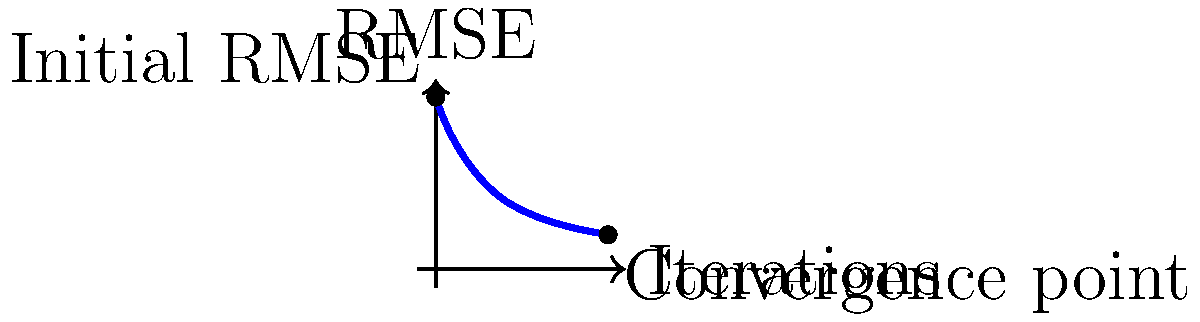Consider a collaborative filtering algorithm for matrix completion, where the convergence is measured by the Root Mean Square Error (RMSE). The graph shows the convergence behavior of the algorithm over iterations. If the algorithm is considered to have converged when the change in RMSE between consecutive iterations is less than ε, and the RMSE function is given by $f(x) = 4e^{-0.4x} + 1$, where x is the number of iterations, at what iteration does the algorithm converge for ε = 0.01? To solve this problem, we need to follow these steps:

1) The convergence criterion is met when the change in RMSE between consecutive iterations is less than ε = 0.01.

2) We can express this mathematically as:
   $|f(x+1) - f(x)| < 0.01$

3) Substituting the given function:
   $|(4e^{-0.4(x+1)} + 1) - (4e^{-0.4x} + 1)| < 0.01$

4) Simplifying:
   $|4e^{-0.4(x+1)} - 4e^{-0.4x}| < 0.01$

5) Factor out $4e^{-0.4x}$:
   $4e^{-0.4x}|e^{-0.4} - 1| < 0.01$

6) Simplify the constant part:
   $4e^{-0.4x}(1 - e^{-0.4}) < 0.01$

7) Solve for x:
   $e^{-0.4x} < \frac{0.01}{4(1 - e^{-0.4})}$

8) Take natural log of both sides:
   $-0.4x < \ln(\frac{0.01}{4(1 - e^{-0.4})})$

9) Solve for x:
   $x > -\frac{1}{0.4}\ln(\frac{0.01}{4(1 - e^{-0.4})}) \approx 11.51$

10) Since we need the first iteration where the condition is met, we round up to the nearest integer.
Answer: 12 iterations 